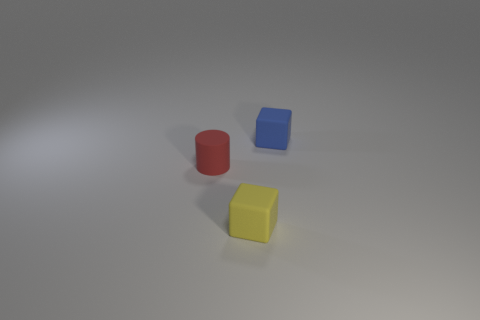Add 3 yellow matte objects. How many objects exist? 6 Subtract all blocks. How many objects are left? 1 Subtract all small red matte cylinders. Subtract all matte cubes. How many objects are left? 0 Add 1 blue cubes. How many blue cubes are left? 2 Add 1 brown matte things. How many brown matte things exist? 1 Subtract 0 green cylinders. How many objects are left? 3 